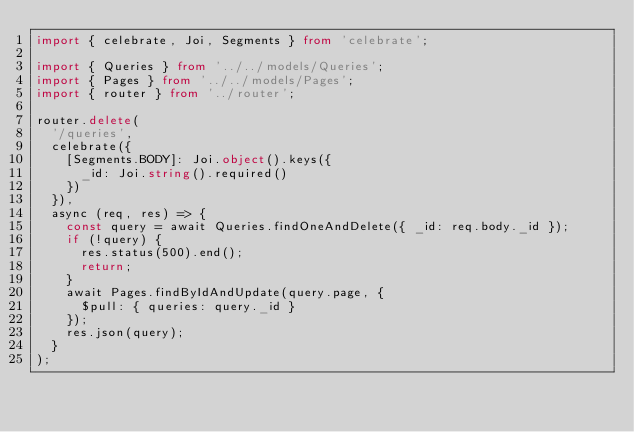Convert code to text. <code><loc_0><loc_0><loc_500><loc_500><_TypeScript_>import { celebrate, Joi, Segments } from 'celebrate';

import { Queries } from '../../models/Queries';
import { Pages } from '../../models/Pages';
import { router } from '../router';

router.delete(
  '/queries',
  celebrate({
    [Segments.BODY]: Joi.object().keys({
      _id: Joi.string().required()
    })
  }),
  async (req, res) => {
    const query = await Queries.findOneAndDelete({ _id: req.body._id });
    if (!query) {
      res.status(500).end();
      return;
    }
    await Pages.findByIdAndUpdate(query.page, {
      $pull: { queries: query._id }
    });
    res.json(query);
  }
);
</code> 